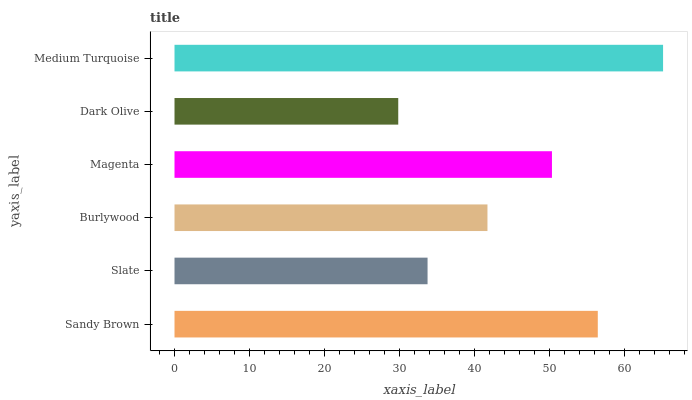Is Dark Olive the minimum?
Answer yes or no. Yes. Is Medium Turquoise the maximum?
Answer yes or no. Yes. Is Slate the minimum?
Answer yes or no. No. Is Slate the maximum?
Answer yes or no. No. Is Sandy Brown greater than Slate?
Answer yes or no. Yes. Is Slate less than Sandy Brown?
Answer yes or no. Yes. Is Slate greater than Sandy Brown?
Answer yes or no. No. Is Sandy Brown less than Slate?
Answer yes or no. No. Is Magenta the high median?
Answer yes or no. Yes. Is Burlywood the low median?
Answer yes or no. Yes. Is Medium Turquoise the high median?
Answer yes or no. No. Is Magenta the low median?
Answer yes or no. No. 